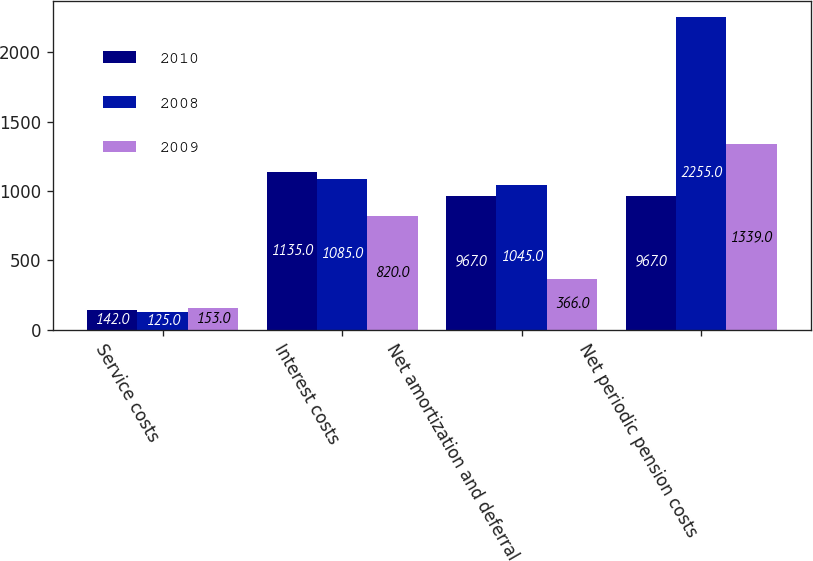<chart> <loc_0><loc_0><loc_500><loc_500><stacked_bar_chart><ecel><fcel>Service costs<fcel>Interest costs<fcel>Net amortization and deferral<fcel>Net periodic pension costs<nl><fcel>2010<fcel>142<fcel>1135<fcel>967<fcel>967<nl><fcel>2008<fcel>125<fcel>1085<fcel>1045<fcel>2255<nl><fcel>2009<fcel>153<fcel>820<fcel>366<fcel>1339<nl></chart> 